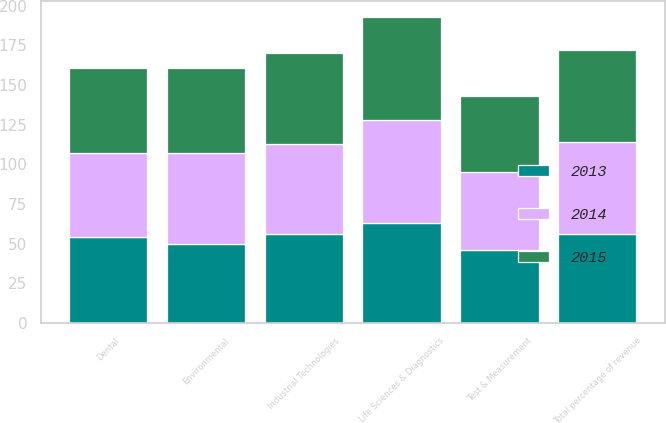<chart> <loc_0><loc_0><loc_500><loc_500><stacked_bar_chart><ecel><fcel>Test & Measurement<fcel>Environmental<fcel>Life Sciences & Diagnostics<fcel>Dental<fcel>Industrial Technologies<fcel>Total percentage of revenue<nl><fcel>2013<fcel>46<fcel>50<fcel>63<fcel>54<fcel>56<fcel>56<nl><fcel>2015<fcel>48<fcel>54<fcel>65<fcel>54<fcel>57<fcel>58<nl><fcel>2014<fcel>49<fcel>57<fcel>65<fcel>53<fcel>57<fcel>58<nl></chart> 